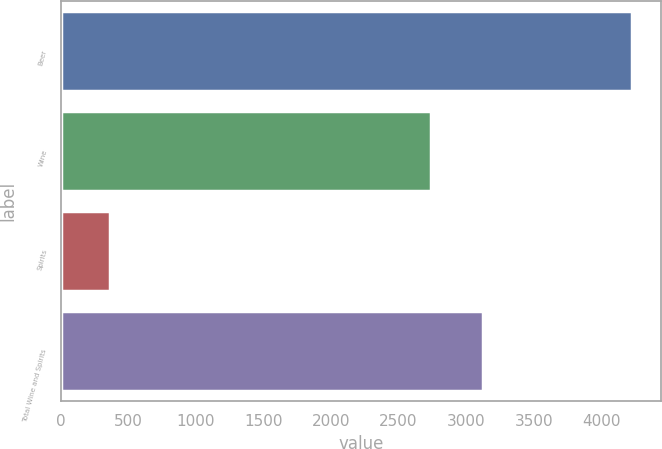Convert chart to OTSL. <chart><loc_0><loc_0><loc_500><loc_500><bar_chart><fcel>Beer<fcel>Wine<fcel>Spirits<fcel>Total Wine and Spirits<nl><fcel>4229.3<fcel>2739.3<fcel>362.9<fcel>3125.94<nl></chart> 